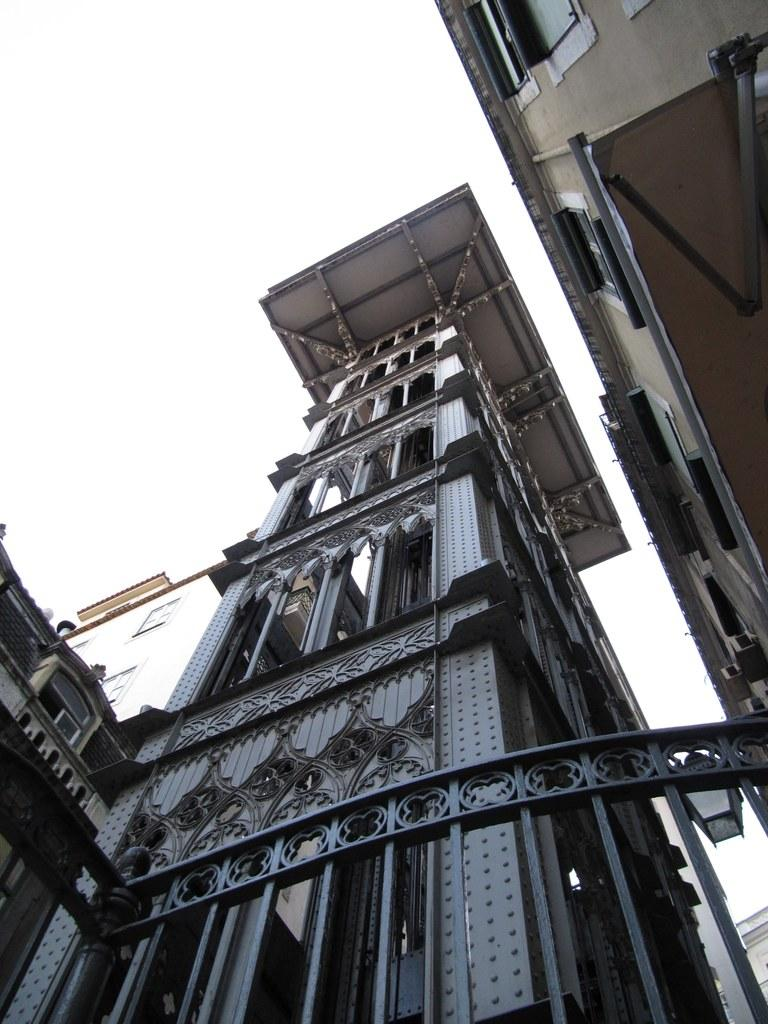What type of structure is the main focus of the image? There is a skyscraper in the image. Are there any other buildings visible in the image? Yes, there are buildings in the image. What can be seen at the top of the image? The sky is visible at the top of the image. What is located at the bottom of the image? There is a gate and a light at the bottom of the image. What industry is being pushed in the image? There is no industry being pushed in the image; it primarily features a skyscraper and other buildings. 